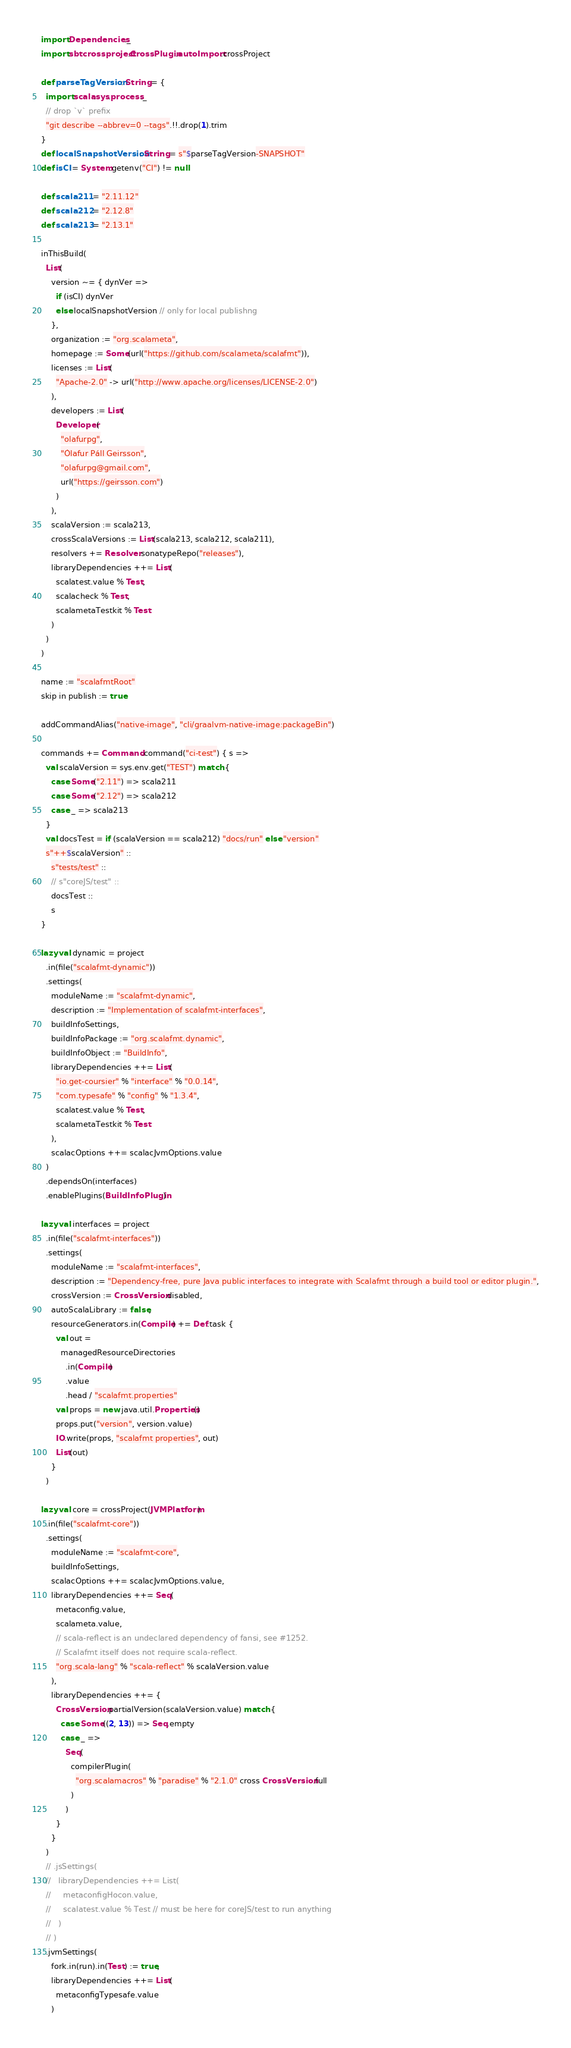Convert code to text. <code><loc_0><loc_0><loc_500><loc_500><_Scala_>import Dependencies._
import sbtcrossproject.CrossPlugin.autoImport.crossProject

def parseTagVersion: String = {
  import scala.sys.process._
  // drop `v` prefix
  "git describe --abbrev=0 --tags".!!.drop(1).trim
}
def localSnapshotVersion: String = s"$parseTagVersion-SNAPSHOT"
def isCI = System.getenv("CI") != null

def scala211 = "2.11.12"
def scala212 = "2.12.8"
def scala213 = "2.13.1"

inThisBuild(
  List(
    version ~= { dynVer =>
      if (isCI) dynVer
      else localSnapshotVersion // only for local publishng
    },
    organization := "org.scalameta",
    homepage := Some(url("https://github.com/scalameta/scalafmt")),
    licenses := List(
      "Apache-2.0" -> url("http://www.apache.org/licenses/LICENSE-2.0")
    ),
    developers := List(
      Developer(
        "olafurpg",
        "Ólafur Páll Geirsson",
        "olafurpg@gmail.com",
        url("https://geirsson.com")
      )
    ),
    scalaVersion := scala213,
    crossScalaVersions := List(scala213, scala212, scala211),
    resolvers += Resolver.sonatypeRepo("releases"),
    libraryDependencies ++= List(
      scalatest.value % Test,
      scalacheck % Test,
      scalametaTestkit % Test
    )
  )
)

name := "scalafmtRoot"
skip in publish := true

addCommandAlias("native-image", "cli/graalvm-native-image:packageBin")

commands += Command.command("ci-test") { s =>
  val scalaVersion = sys.env.get("TEST") match {
    case Some("2.11") => scala211
    case Some("2.12") => scala212
    case _ => scala213
  }
  val docsTest = if (scalaVersion == scala212) "docs/run" else "version"
  s"++$scalaVersion" ::
    s"tests/test" ::
    // s"coreJS/test" ::
    docsTest ::
    s
}

lazy val dynamic = project
  .in(file("scalafmt-dynamic"))
  .settings(
    moduleName := "scalafmt-dynamic",
    description := "Implementation of scalafmt-interfaces",
    buildInfoSettings,
    buildInfoPackage := "org.scalafmt.dynamic",
    buildInfoObject := "BuildInfo",
    libraryDependencies ++= List(
      "io.get-coursier" % "interface" % "0.0.14",
      "com.typesafe" % "config" % "1.3.4",
      scalatest.value % Test,
      scalametaTestkit % Test
    ),
    scalacOptions ++= scalacJvmOptions.value
  )
  .dependsOn(interfaces)
  .enablePlugins(BuildInfoPlugin)

lazy val interfaces = project
  .in(file("scalafmt-interfaces"))
  .settings(
    moduleName := "scalafmt-interfaces",
    description := "Dependency-free, pure Java public interfaces to integrate with Scalafmt through a build tool or editor plugin.",
    crossVersion := CrossVersion.disabled,
    autoScalaLibrary := false,
    resourceGenerators.in(Compile) += Def.task {
      val out =
        managedResourceDirectories
          .in(Compile)
          .value
          .head / "scalafmt.properties"
      val props = new java.util.Properties()
      props.put("version", version.value)
      IO.write(props, "scalafmt properties", out)
      List(out)
    }
  )

lazy val core = crossProject(JVMPlatform)
  .in(file("scalafmt-core"))
  .settings(
    moduleName := "scalafmt-core",
    buildInfoSettings,
    scalacOptions ++= scalacJvmOptions.value,
    libraryDependencies ++= Seq(
      metaconfig.value,
      scalameta.value,
      // scala-reflect is an undeclared dependency of fansi, see #1252.
      // Scalafmt itself does not require scala-reflect.
      "org.scala-lang" % "scala-reflect" % scalaVersion.value
    ),
    libraryDependencies ++= {
      CrossVersion.partialVersion(scalaVersion.value) match {
        case Some((2, 13)) => Seq.empty
        case _ =>
          Seq(
            compilerPlugin(
              "org.scalamacros" % "paradise" % "2.1.0" cross CrossVersion.full
            )
          )
      }
    }
  )
  // .jsSettings(
  //   libraryDependencies ++= List(
  //     metaconfigHocon.value,
  //     scalatest.value % Test // must be here for coreJS/test to run anything
  //   )
  // )
  .jvmSettings(
    fork.in(run).in(Test) := true,
    libraryDependencies ++= List(
      metaconfigTypesafe.value
    )</code> 